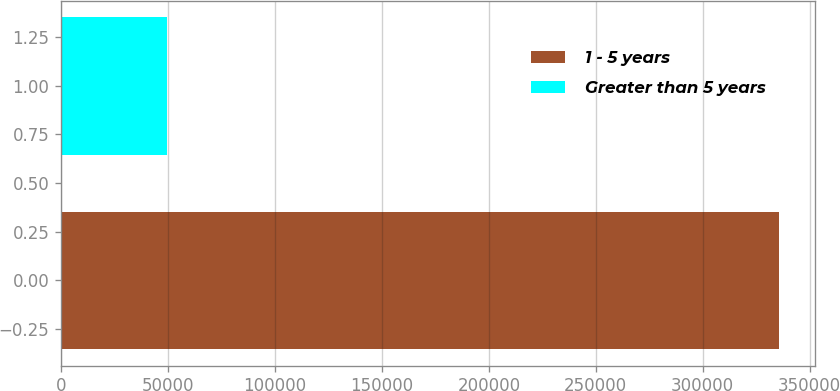Convert chart to OTSL. <chart><loc_0><loc_0><loc_500><loc_500><bar_chart><fcel>1 - 5 years<fcel>Greater than 5 years<nl><fcel>335872<fcel>49440<nl></chart> 